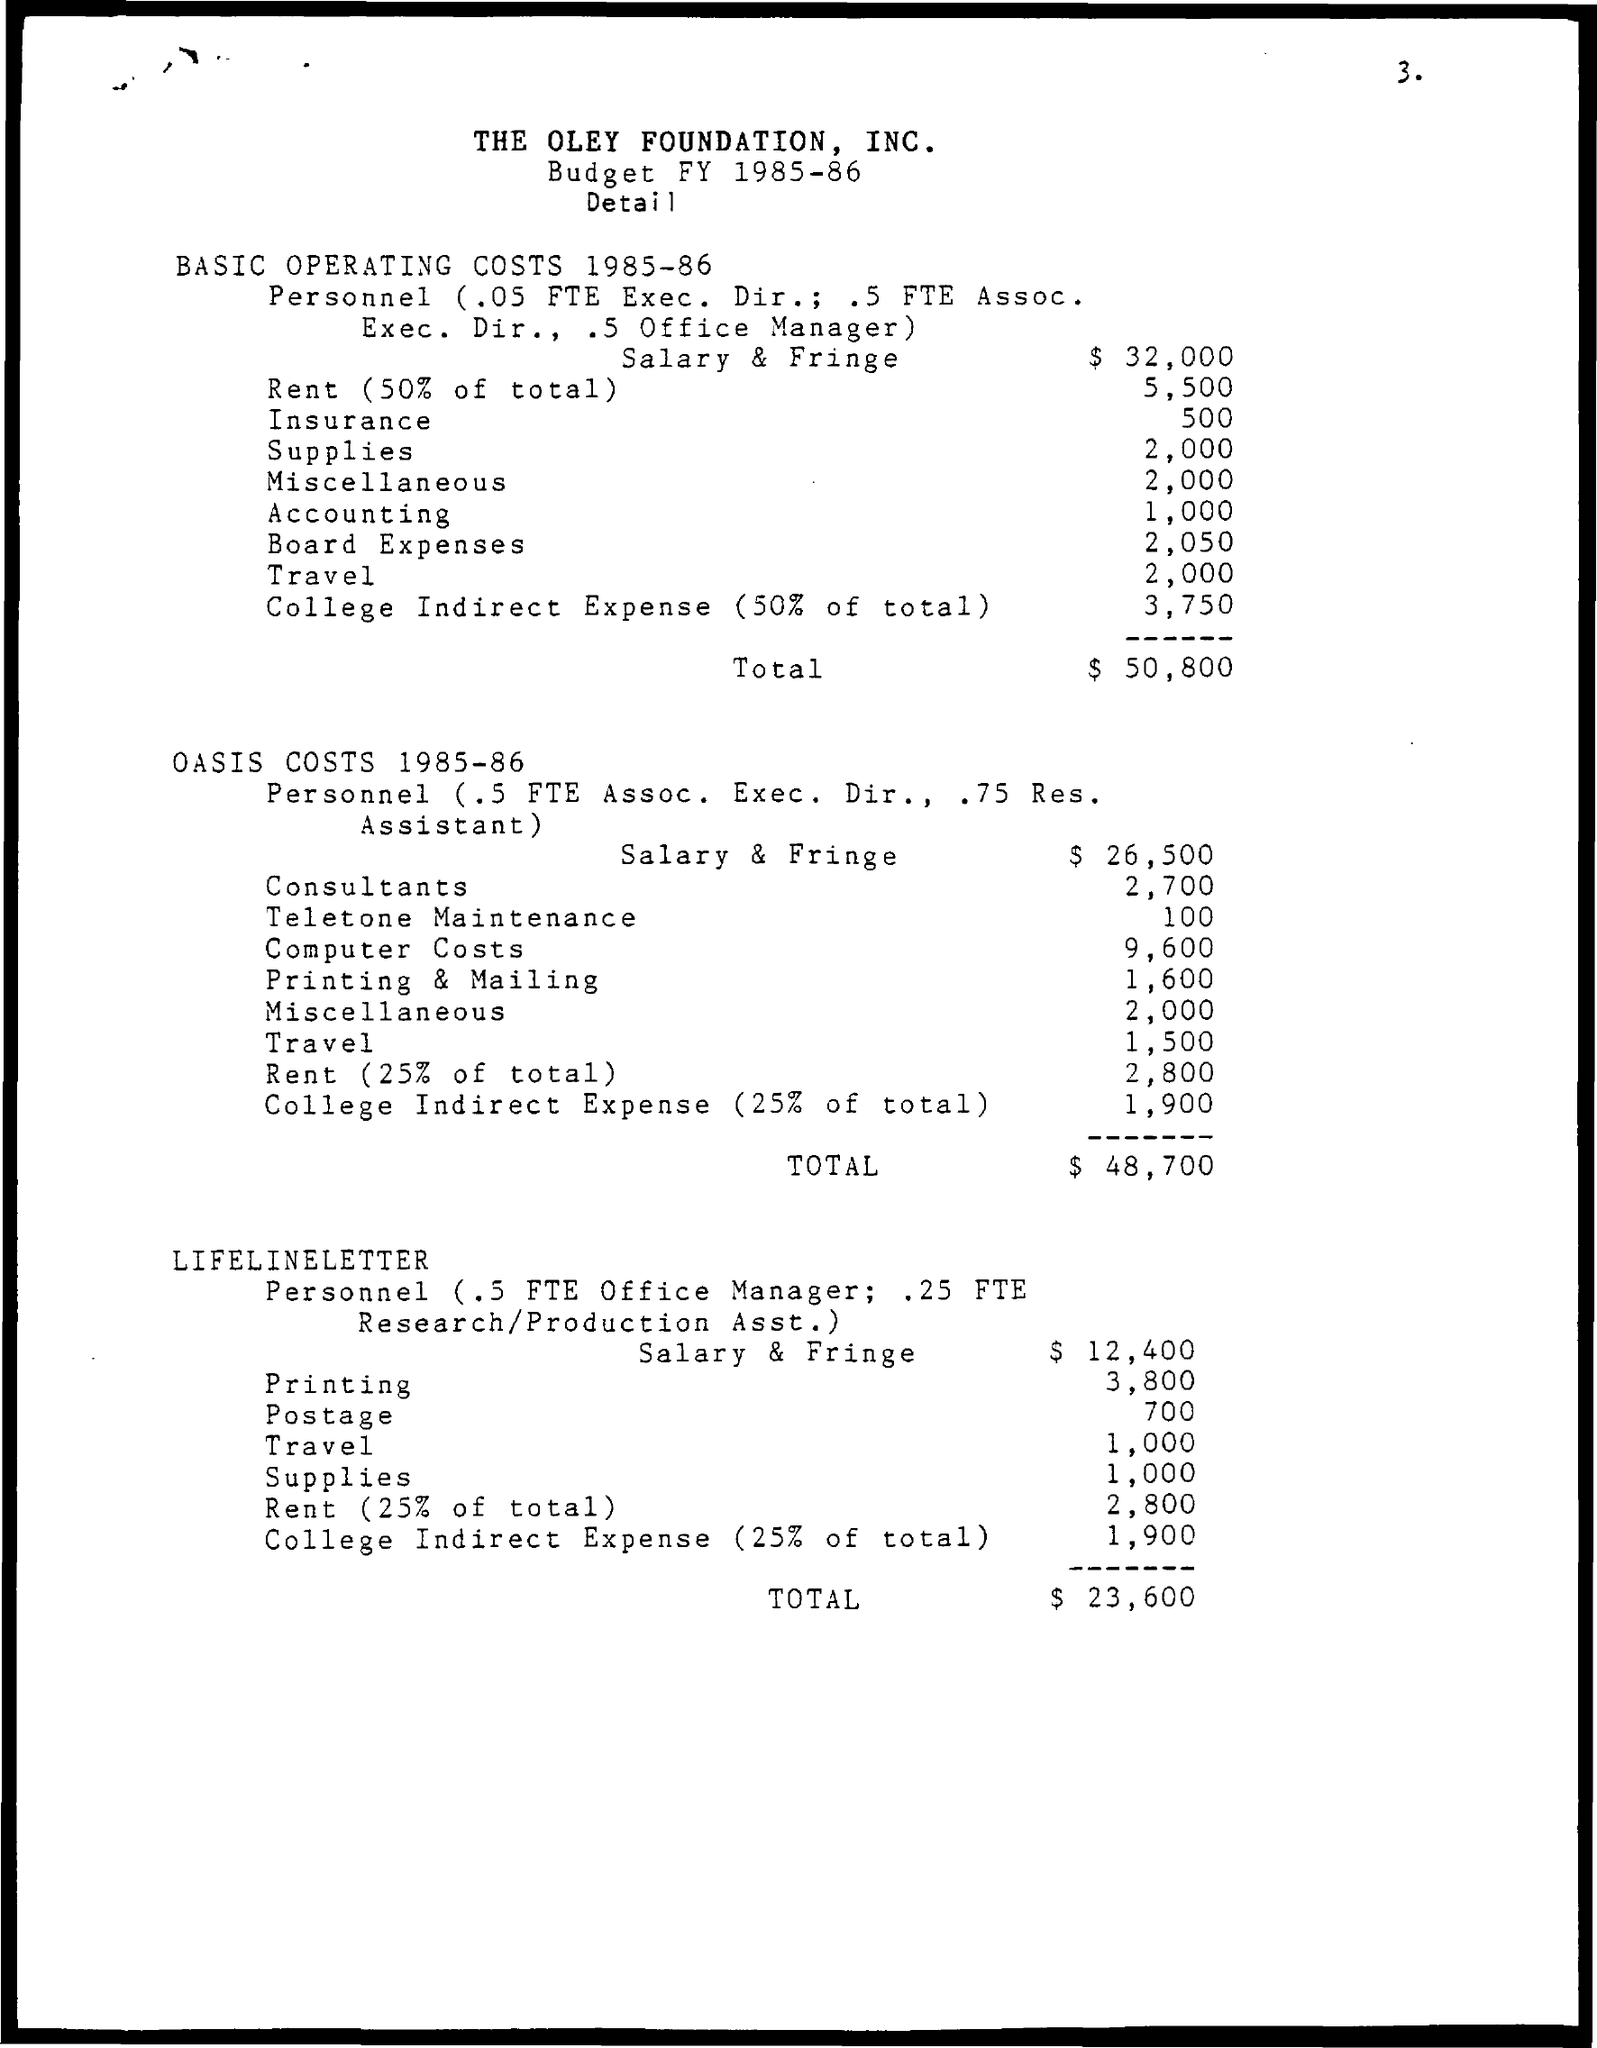Specify some key components in this picture. The expense for accounting is 1,000. The expenses of the Board are 2,050... What is the insurance policy for 500?" is a question that seeks to clarify the details of an insurance policy for an amount of 500. 